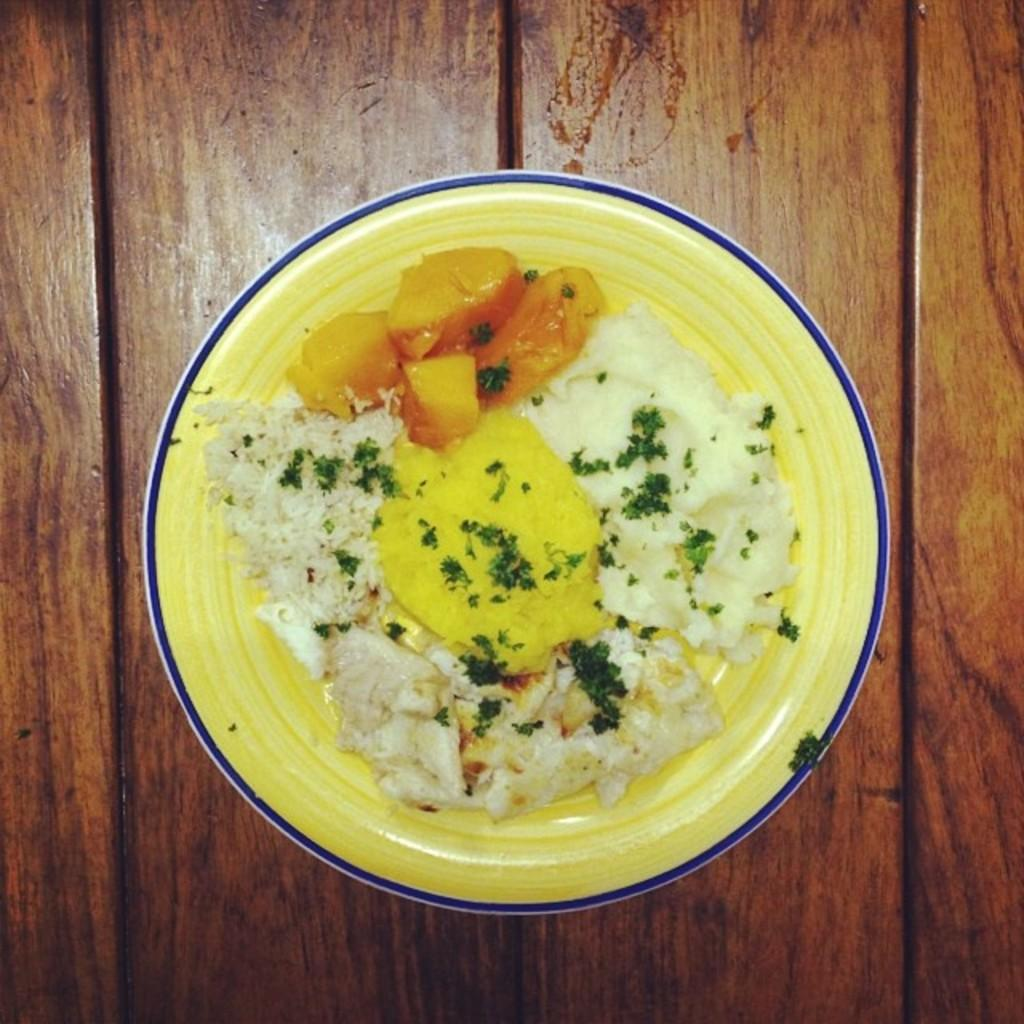What is the main food item visible in the image? There is a food item served in a plate in the image. Where is the plate with the food item located? The plate is placed on a table. What type of curtain is hanging near the food item in the image? There is no curtain present in the image. How many trees can be seen around the table in the image? There are no trees visible in the image. 